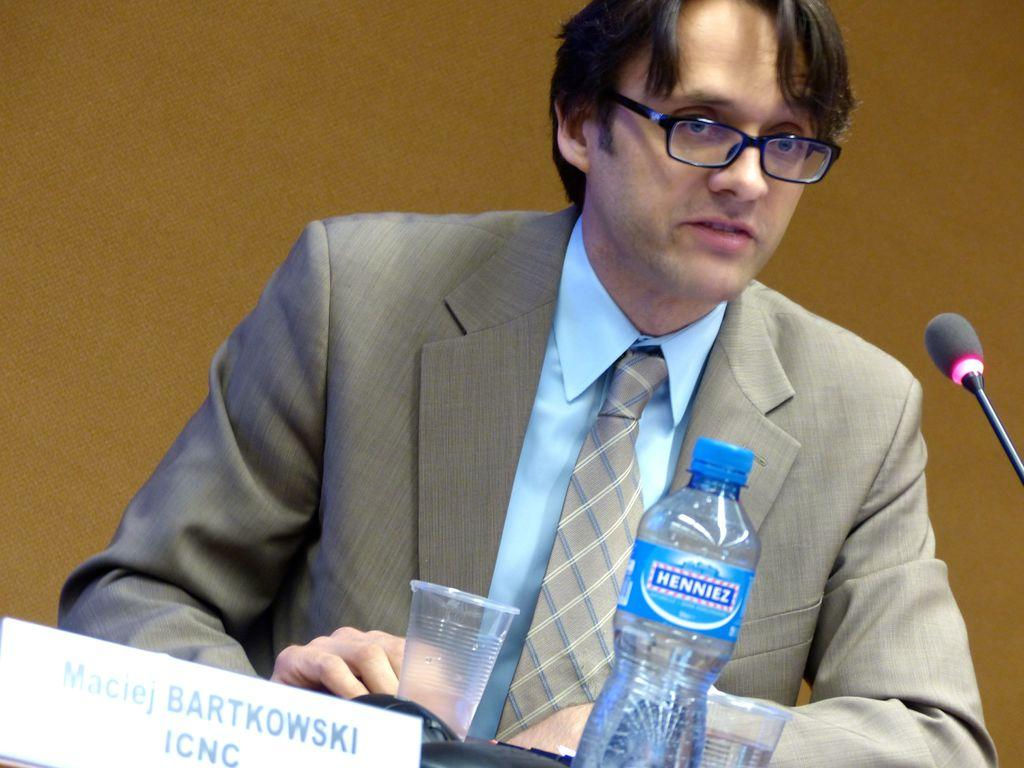What is the main subject of the image? There is a person in the image. What is the person wearing? The person is wearing a suit. What is the person doing in the image? The person is sitting on a table. What objects are in front of the person? There is a microphone, a water bottle, and glasses in front of the person. What religious organization does the person belong to in the image? There is no information about the person's religious affiliation in the image. How does the person's mother feel about their choice of attire in the image? There is no information about the person's mother or their opinion on the person's attire in the image. 